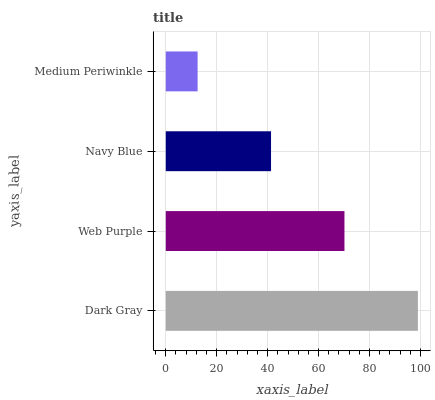Is Medium Periwinkle the minimum?
Answer yes or no. Yes. Is Dark Gray the maximum?
Answer yes or no. Yes. Is Web Purple the minimum?
Answer yes or no. No. Is Web Purple the maximum?
Answer yes or no. No. Is Dark Gray greater than Web Purple?
Answer yes or no. Yes. Is Web Purple less than Dark Gray?
Answer yes or no. Yes. Is Web Purple greater than Dark Gray?
Answer yes or no. No. Is Dark Gray less than Web Purple?
Answer yes or no. No. Is Web Purple the high median?
Answer yes or no. Yes. Is Navy Blue the low median?
Answer yes or no. Yes. Is Navy Blue the high median?
Answer yes or no. No. Is Web Purple the low median?
Answer yes or no. No. 